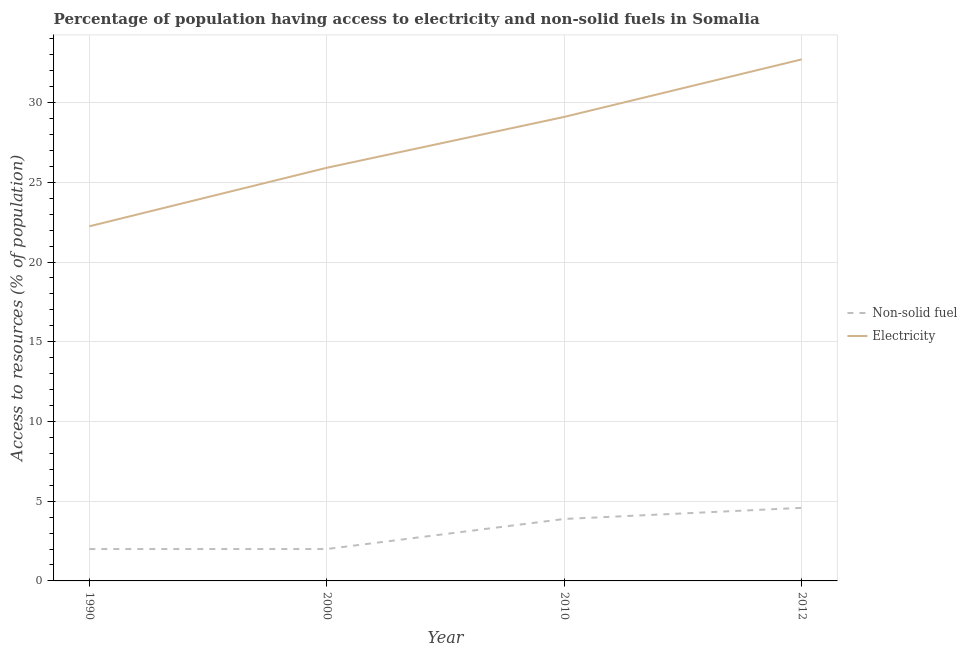Is the number of lines equal to the number of legend labels?
Your response must be concise. Yes. What is the percentage of population having access to electricity in 1990?
Your response must be concise. 22.24. Across all years, what is the maximum percentage of population having access to electricity?
Provide a short and direct response. 32.71. Across all years, what is the minimum percentage of population having access to electricity?
Provide a succinct answer. 22.24. In which year was the percentage of population having access to electricity minimum?
Offer a terse response. 1990. What is the total percentage of population having access to electricity in the graph?
Your response must be concise. 109.96. What is the difference between the percentage of population having access to non-solid fuel in 1990 and that in 2000?
Your response must be concise. 0. What is the difference between the percentage of population having access to electricity in 2010 and the percentage of population having access to non-solid fuel in 2012?
Your answer should be compact. 24.52. What is the average percentage of population having access to electricity per year?
Offer a very short reply. 27.49. In the year 1990, what is the difference between the percentage of population having access to non-solid fuel and percentage of population having access to electricity?
Provide a short and direct response. -20.24. What is the ratio of the percentage of population having access to electricity in 2000 to that in 2010?
Offer a very short reply. 0.89. Is the difference between the percentage of population having access to electricity in 1990 and 2010 greater than the difference between the percentage of population having access to non-solid fuel in 1990 and 2010?
Provide a short and direct response. No. What is the difference between the highest and the second highest percentage of population having access to electricity?
Make the answer very short. 3.61. What is the difference between the highest and the lowest percentage of population having access to non-solid fuel?
Keep it short and to the point. 2.58. Is the sum of the percentage of population having access to non-solid fuel in 2010 and 2012 greater than the maximum percentage of population having access to electricity across all years?
Your answer should be compact. No. Does the percentage of population having access to non-solid fuel monotonically increase over the years?
Offer a terse response. No. How many lines are there?
Provide a succinct answer. 2. How many years are there in the graph?
Your answer should be compact. 4. Are the values on the major ticks of Y-axis written in scientific E-notation?
Keep it short and to the point. No. Does the graph contain any zero values?
Keep it short and to the point. No. Does the graph contain grids?
Offer a terse response. Yes. How many legend labels are there?
Your response must be concise. 2. How are the legend labels stacked?
Give a very brief answer. Vertical. What is the title of the graph?
Ensure brevity in your answer.  Percentage of population having access to electricity and non-solid fuels in Somalia. Does "Highest 10% of population" appear as one of the legend labels in the graph?
Provide a short and direct response. No. What is the label or title of the Y-axis?
Ensure brevity in your answer.  Access to resources (% of population). What is the Access to resources (% of population) in Non-solid fuel in 1990?
Provide a succinct answer. 2. What is the Access to resources (% of population) of Electricity in 1990?
Give a very brief answer. 22.24. What is the Access to resources (% of population) in Non-solid fuel in 2000?
Keep it short and to the point. 2. What is the Access to resources (% of population) of Electricity in 2000?
Your answer should be compact. 25.91. What is the Access to resources (% of population) in Non-solid fuel in 2010?
Give a very brief answer. 3.89. What is the Access to resources (% of population) in Electricity in 2010?
Ensure brevity in your answer.  29.1. What is the Access to resources (% of population) in Non-solid fuel in 2012?
Offer a very short reply. 4.58. What is the Access to resources (% of population) in Electricity in 2012?
Provide a succinct answer. 32.71. Across all years, what is the maximum Access to resources (% of population) in Non-solid fuel?
Ensure brevity in your answer.  4.58. Across all years, what is the maximum Access to resources (% of population) of Electricity?
Give a very brief answer. 32.71. Across all years, what is the minimum Access to resources (% of population) in Non-solid fuel?
Make the answer very short. 2. Across all years, what is the minimum Access to resources (% of population) in Electricity?
Offer a terse response. 22.24. What is the total Access to resources (% of population) of Non-solid fuel in the graph?
Give a very brief answer. 12.47. What is the total Access to resources (% of population) of Electricity in the graph?
Provide a succinct answer. 109.96. What is the difference between the Access to resources (% of population) of Electricity in 1990 and that in 2000?
Offer a terse response. -3.67. What is the difference between the Access to resources (% of population) in Non-solid fuel in 1990 and that in 2010?
Ensure brevity in your answer.  -1.89. What is the difference between the Access to resources (% of population) in Electricity in 1990 and that in 2010?
Your answer should be very brief. -6.86. What is the difference between the Access to resources (% of population) in Non-solid fuel in 1990 and that in 2012?
Your response must be concise. -2.58. What is the difference between the Access to resources (% of population) in Electricity in 1990 and that in 2012?
Offer a very short reply. -10.47. What is the difference between the Access to resources (% of population) in Non-solid fuel in 2000 and that in 2010?
Your answer should be very brief. -1.89. What is the difference between the Access to resources (% of population) in Electricity in 2000 and that in 2010?
Make the answer very short. -3.19. What is the difference between the Access to resources (% of population) of Non-solid fuel in 2000 and that in 2012?
Ensure brevity in your answer.  -2.58. What is the difference between the Access to resources (% of population) of Electricity in 2000 and that in 2012?
Provide a short and direct response. -6.8. What is the difference between the Access to resources (% of population) of Non-solid fuel in 2010 and that in 2012?
Ensure brevity in your answer.  -0.7. What is the difference between the Access to resources (% of population) of Electricity in 2010 and that in 2012?
Your answer should be compact. -3.61. What is the difference between the Access to resources (% of population) of Non-solid fuel in 1990 and the Access to resources (% of population) of Electricity in 2000?
Ensure brevity in your answer.  -23.91. What is the difference between the Access to resources (% of population) in Non-solid fuel in 1990 and the Access to resources (% of population) in Electricity in 2010?
Provide a short and direct response. -27.1. What is the difference between the Access to resources (% of population) of Non-solid fuel in 1990 and the Access to resources (% of population) of Electricity in 2012?
Your response must be concise. -30.71. What is the difference between the Access to resources (% of population) in Non-solid fuel in 2000 and the Access to resources (% of population) in Electricity in 2010?
Offer a very short reply. -27.1. What is the difference between the Access to resources (% of population) in Non-solid fuel in 2000 and the Access to resources (% of population) in Electricity in 2012?
Give a very brief answer. -30.71. What is the difference between the Access to resources (% of population) in Non-solid fuel in 2010 and the Access to resources (% of population) in Electricity in 2012?
Make the answer very short. -28.82. What is the average Access to resources (% of population) of Non-solid fuel per year?
Keep it short and to the point. 3.12. What is the average Access to resources (% of population) in Electricity per year?
Your answer should be very brief. 27.49. In the year 1990, what is the difference between the Access to resources (% of population) of Non-solid fuel and Access to resources (% of population) of Electricity?
Offer a terse response. -20.24. In the year 2000, what is the difference between the Access to resources (% of population) in Non-solid fuel and Access to resources (% of population) in Electricity?
Give a very brief answer. -23.91. In the year 2010, what is the difference between the Access to resources (% of population) of Non-solid fuel and Access to resources (% of population) of Electricity?
Give a very brief answer. -25.21. In the year 2012, what is the difference between the Access to resources (% of population) in Non-solid fuel and Access to resources (% of population) in Electricity?
Offer a very short reply. -28.12. What is the ratio of the Access to resources (% of population) in Electricity in 1990 to that in 2000?
Offer a very short reply. 0.86. What is the ratio of the Access to resources (% of population) in Non-solid fuel in 1990 to that in 2010?
Your answer should be compact. 0.51. What is the ratio of the Access to resources (% of population) of Electricity in 1990 to that in 2010?
Provide a succinct answer. 0.76. What is the ratio of the Access to resources (% of population) of Non-solid fuel in 1990 to that in 2012?
Offer a very short reply. 0.44. What is the ratio of the Access to resources (% of population) of Electricity in 1990 to that in 2012?
Provide a short and direct response. 0.68. What is the ratio of the Access to resources (% of population) of Non-solid fuel in 2000 to that in 2010?
Provide a succinct answer. 0.51. What is the ratio of the Access to resources (% of population) of Electricity in 2000 to that in 2010?
Offer a terse response. 0.89. What is the ratio of the Access to resources (% of population) of Non-solid fuel in 2000 to that in 2012?
Your answer should be compact. 0.44. What is the ratio of the Access to resources (% of population) in Electricity in 2000 to that in 2012?
Provide a short and direct response. 0.79. What is the ratio of the Access to resources (% of population) of Non-solid fuel in 2010 to that in 2012?
Offer a very short reply. 0.85. What is the ratio of the Access to resources (% of population) in Electricity in 2010 to that in 2012?
Your answer should be compact. 0.89. What is the difference between the highest and the second highest Access to resources (% of population) of Non-solid fuel?
Give a very brief answer. 0.7. What is the difference between the highest and the second highest Access to resources (% of population) in Electricity?
Your answer should be very brief. 3.61. What is the difference between the highest and the lowest Access to resources (% of population) of Non-solid fuel?
Provide a short and direct response. 2.58. What is the difference between the highest and the lowest Access to resources (% of population) of Electricity?
Keep it short and to the point. 10.47. 